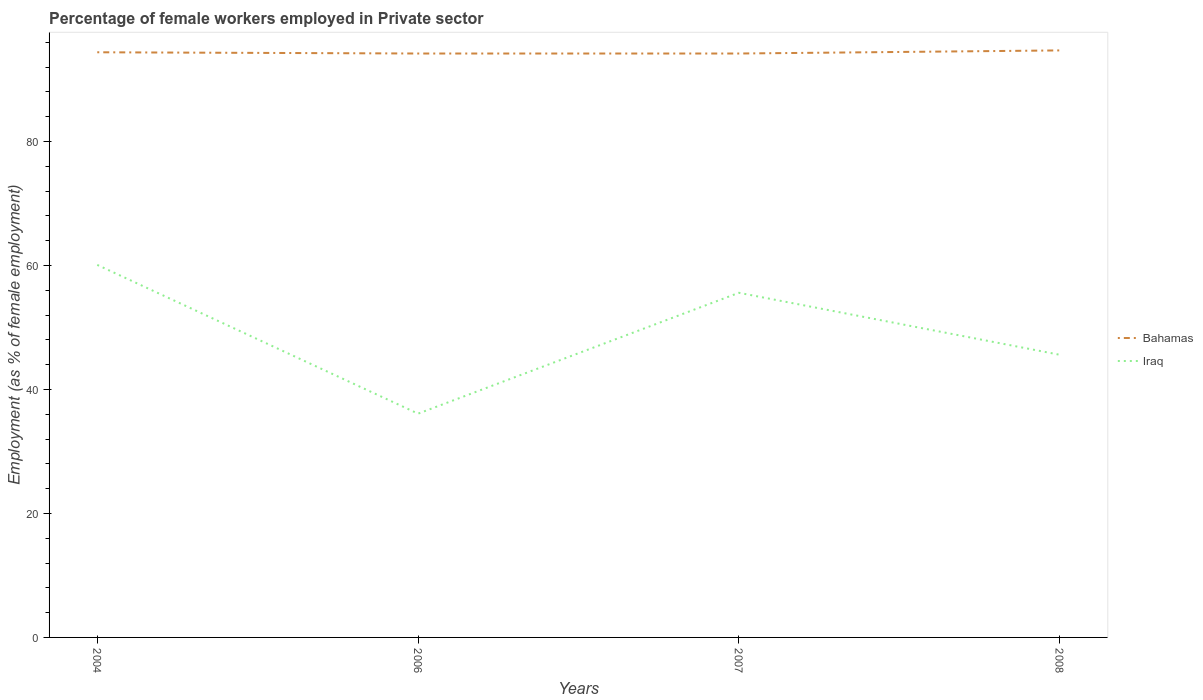Does the line corresponding to Bahamas intersect with the line corresponding to Iraq?
Offer a terse response. No. Across all years, what is the maximum percentage of females employed in Private sector in Iraq?
Provide a short and direct response. 36.1. In which year was the percentage of females employed in Private sector in Iraq maximum?
Your answer should be very brief. 2006. What is the total percentage of females employed in Private sector in Bahamas in the graph?
Give a very brief answer. -0.3. What is the difference between the highest and the lowest percentage of females employed in Private sector in Bahamas?
Make the answer very short. 2. Are the values on the major ticks of Y-axis written in scientific E-notation?
Your answer should be very brief. No. How many legend labels are there?
Give a very brief answer. 2. What is the title of the graph?
Offer a very short reply. Percentage of female workers employed in Private sector. Does "Liechtenstein" appear as one of the legend labels in the graph?
Ensure brevity in your answer.  No. What is the label or title of the X-axis?
Give a very brief answer. Years. What is the label or title of the Y-axis?
Keep it short and to the point. Employment (as % of female employment). What is the Employment (as % of female employment) of Bahamas in 2004?
Keep it short and to the point. 94.4. What is the Employment (as % of female employment) of Iraq in 2004?
Make the answer very short. 60.1. What is the Employment (as % of female employment) in Bahamas in 2006?
Provide a succinct answer. 94.2. What is the Employment (as % of female employment) in Iraq in 2006?
Keep it short and to the point. 36.1. What is the Employment (as % of female employment) of Bahamas in 2007?
Make the answer very short. 94.2. What is the Employment (as % of female employment) of Iraq in 2007?
Keep it short and to the point. 55.6. What is the Employment (as % of female employment) of Bahamas in 2008?
Provide a succinct answer. 94.7. What is the Employment (as % of female employment) in Iraq in 2008?
Give a very brief answer. 45.6. Across all years, what is the maximum Employment (as % of female employment) in Bahamas?
Make the answer very short. 94.7. Across all years, what is the maximum Employment (as % of female employment) of Iraq?
Provide a short and direct response. 60.1. Across all years, what is the minimum Employment (as % of female employment) in Bahamas?
Offer a terse response. 94.2. Across all years, what is the minimum Employment (as % of female employment) of Iraq?
Your response must be concise. 36.1. What is the total Employment (as % of female employment) of Bahamas in the graph?
Your answer should be very brief. 377.5. What is the total Employment (as % of female employment) of Iraq in the graph?
Ensure brevity in your answer.  197.4. What is the difference between the Employment (as % of female employment) of Iraq in 2004 and that in 2006?
Ensure brevity in your answer.  24. What is the difference between the Employment (as % of female employment) of Iraq in 2004 and that in 2007?
Provide a short and direct response. 4.5. What is the difference between the Employment (as % of female employment) of Iraq in 2006 and that in 2007?
Offer a terse response. -19.5. What is the difference between the Employment (as % of female employment) in Bahamas in 2006 and that in 2008?
Your response must be concise. -0.5. What is the difference between the Employment (as % of female employment) in Bahamas in 2007 and that in 2008?
Give a very brief answer. -0.5. What is the difference between the Employment (as % of female employment) of Iraq in 2007 and that in 2008?
Keep it short and to the point. 10. What is the difference between the Employment (as % of female employment) of Bahamas in 2004 and the Employment (as % of female employment) of Iraq in 2006?
Give a very brief answer. 58.3. What is the difference between the Employment (as % of female employment) in Bahamas in 2004 and the Employment (as % of female employment) in Iraq in 2007?
Provide a succinct answer. 38.8. What is the difference between the Employment (as % of female employment) in Bahamas in 2004 and the Employment (as % of female employment) in Iraq in 2008?
Your response must be concise. 48.8. What is the difference between the Employment (as % of female employment) of Bahamas in 2006 and the Employment (as % of female employment) of Iraq in 2007?
Make the answer very short. 38.6. What is the difference between the Employment (as % of female employment) in Bahamas in 2006 and the Employment (as % of female employment) in Iraq in 2008?
Your answer should be very brief. 48.6. What is the difference between the Employment (as % of female employment) of Bahamas in 2007 and the Employment (as % of female employment) of Iraq in 2008?
Offer a terse response. 48.6. What is the average Employment (as % of female employment) of Bahamas per year?
Your response must be concise. 94.38. What is the average Employment (as % of female employment) of Iraq per year?
Offer a very short reply. 49.35. In the year 2004, what is the difference between the Employment (as % of female employment) of Bahamas and Employment (as % of female employment) of Iraq?
Give a very brief answer. 34.3. In the year 2006, what is the difference between the Employment (as % of female employment) of Bahamas and Employment (as % of female employment) of Iraq?
Offer a terse response. 58.1. In the year 2007, what is the difference between the Employment (as % of female employment) in Bahamas and Employment (as % of female employment) in Iraq?
Offer a very short reply. 38.6. In the year 2008, what is the difference between the Employment (as % of female employment) in Bahamas and Employment (as % of female employment) in Iraq?
Give a very brief answer. 49.1. What is the ratio of the Employment (as % of female employment) in Iraq in 2004 to that in 2006?
Make the answer very short. 1.66. What is the ratio of the Employment (as % of female employment) in Iraq in 2004 to that in 2007?
Ensure brevity in your answer.  1.08. What is the ratio of the Employment (as % of female employment) of Iraq in 2004 to that in 2008?
Offer a very short reply. 1.32. What is the ratio of the Employment (as % of female employment) in Iraq in 2006 to that in 2007?
Keep it short and to the point. 0.65. What is the ratio of the Employment (as % of female employment) of Iraq in 2006 to that in 2008?
Offer a very short reply. 0.79. What is the ratio of the Employment (as % of female employment) in Iraq in 2007 to that in 2008?
Make the answer very short. 1.22. What is the difference between the highest and the second highest Employment (as % of female employment) of Bahamas?
Your answer should be very brief. 0.3. What is the difference between the highest and the second highest Employment (as % of female employment) in Iraq?
Give a very brief answer. 4.5. What is the difference between the highest and the lowest Employment (as % of female employment) of Bahamas?
Make the answer very short. 0.5. What is the difference between the highest and the lowest Employment (as % of female employment) in Iraq?
Provide a short and direct response. 24. 